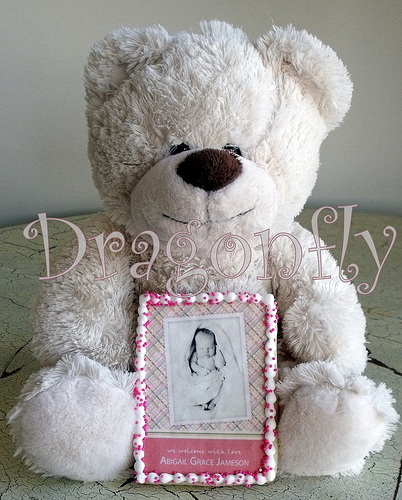<image>
Can you confirm if the writing is on the bear? No. The writing is not positioned on the bear. They may be near each other, but the writing is not supported by or resting on top of the bear. 